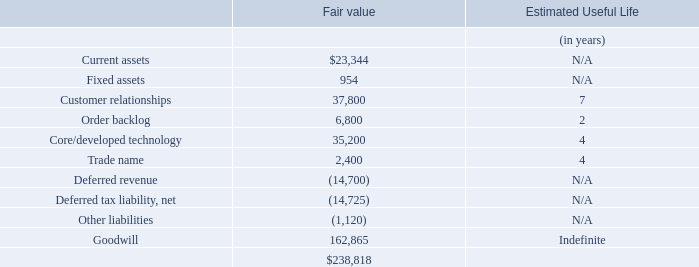2018 Acquisition
Wombat Security Technologies, Inc.
On February 28, 2018 (the “Wombat Acquisition Date”), pursuant to the terms of the merger agreement, the Company acquired all shares of Wombat Security Technologies, Inc. (“Wombat”), a leader for phishing simulation and security awareness computer-based training. By collecting data from Wombat’s PhishAlarm solution, the Company has access to data on phishing campaigns as seen by non-Company customers, providing broader visibility and insight to the Proofpoint Nexus platform.
With this acquisition, the Company’s customers can leverage the industry’s first solution combining the Company’s advanced threat protection with Wombat’s phishing simulation and computer-based security awareness training. With the combined solutions, the Company’s customers can:
use real detected phishing attacks for simulations, assessing users based on the threats that are actually targeting them; both investigate and take action on user-reporting phishing, leveraging orchestration and automation to find real attacks, quarantine emails in users’ inboxes, and lock user accounts to limit risk; and train users in the moment immediately after they click for both simulated and real phishing attacks.
The Company also expects to achieve savings in corporate overhead costs for the combined entities. These factors, among others, contributed to a purchase price in excess of the estimated fair value of acquired net identifiable assets and, as a result, goodwill was recorded in connection with the acquisition.
Proofpoint, Inc. Notes to Consolidated Financial Statements (Continued) (dollars and share amounts in thousands, except per share amounts)
At the Wombat Acquisition Date, the consideration transferred was $225,366, net of cash acquired of $13,452.
Per the terms of the merger agreement, unvested in-the-money stock options held by Wombat employees were canceled and paid off using the same amount per option as for the common share less applicable exercise price for each option. The fair value of $1,580 of these unvested options was attributed to pre-combination service and included in consideration transferred. The fair value of unvested options of $1,571 was allocated to post-combination services and expensed in the three months ended March 31, 2018. Also, as part of the merger agreement, 51 shares of the Company’s common stock were deferred for certain key employees with the total fair value of $5,458 (see Note 11 “Equity Award Plans”), which was not included in the purchase price. The deferred shares are subject to forfeiture if employment terminates prior to the lapse of the restrictions, and their fair value is expensed as stock-based compensation expense over the remaining service period.
The following table summarizes the fair values of tangible assets acquired, liabilities assumed, intangible assets and goodwill:
In what aspects is Proofpoint trying to achieve savings in? Corporate overhead costs for the combined entities. Under what conditions will the deferred shares be subjected to forfeiture? If employment terminates prior to the lapse of the restrictions, and their fair value is expensed as stock-based compensation expense over the remaining service period. How long is the estimated useful life for the Goodwill? Indefinite. What is the difference in estimated fair value between current assets and fixed assets?
Answer scale should be: thousand. $23,344 - 954
Answer: 22390. What is the average estimated fair value of Customer relationships?
Answer scale should be: thousand. 37,800 / 7
Answer: 5400. What is the total estimated fair value of all assets?
Answer scale should be: thousand. $23,344 + 954 + 37,800 + 6,800 + 35,200 + 2,400
Answer: 106498. 